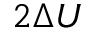<formula> <loc_0><loc_0><loc_500><loc_500>2 \Delta U</formula> 